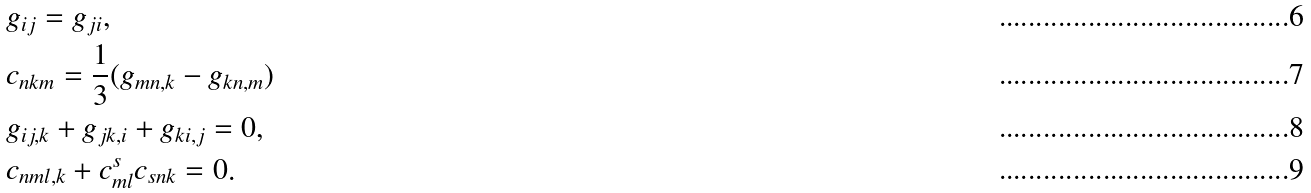<formula> <loc_0><loc_0><loc_500><loc_500>& g _ { i j } = g _ { j i } , \\ & c _ { n k m } = \frac { 1 } { 3 } ( g _ { m n , k } - g _ { k n , m } ) \\ & g _ { i j , k } + g _ { j k , i } + g _ { k i , j } = 0 , \\ & c _ { n m l , k } + c ^ { s } _ { m l } c _ { s n k } = 0 .</formula> 